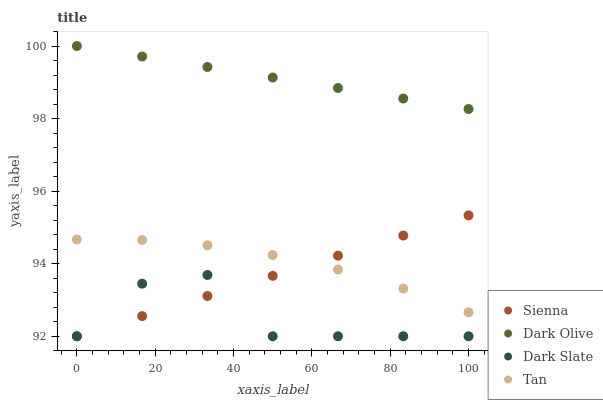Does Dark Slate have the minimum area under the curve?
Answer yes or no. Yes. Does Dark Olive have the maximum area under the curve?
Answer yes or no. Yes. Does Tan have the minimum area under the curve?
Answer yes or no. No. Does Tan have the maximum area under the curve?
Answer yes or no. No. Is Sienna the smoothest?
Answer yes or no. Yes. Is Dark Slate the roughest?
Answer yes or no. Yes. Is Tan the smoothest?
Answer yes or no. No. Is Tan the roughest?
Answer yes or no. No. Does Sienna have the lowest value?
Answer yes or no. Yes. Does Tan have the lowest value?
Answer yes or no. No. Does Dark Olive have the highest value?
Answer yes or no. Yes. Does Tan have the highest value?
Answer yes or no. No. Is Dark Slate less than Tan?
Answer yes or no. Yes. Is Dark Olive greater than Dark Slate?
Answer yes or no. Yes. Does Sienna intersect Dark Slate?
Answer yes or no. Yes. Is Sienna less than Dark Slate?
Answer yes or no. No. Is Sienna greater than Dark Slate?
Answer yes or no. No. Does Dark Slate intersect Tan?
Answer yes or no. No. 